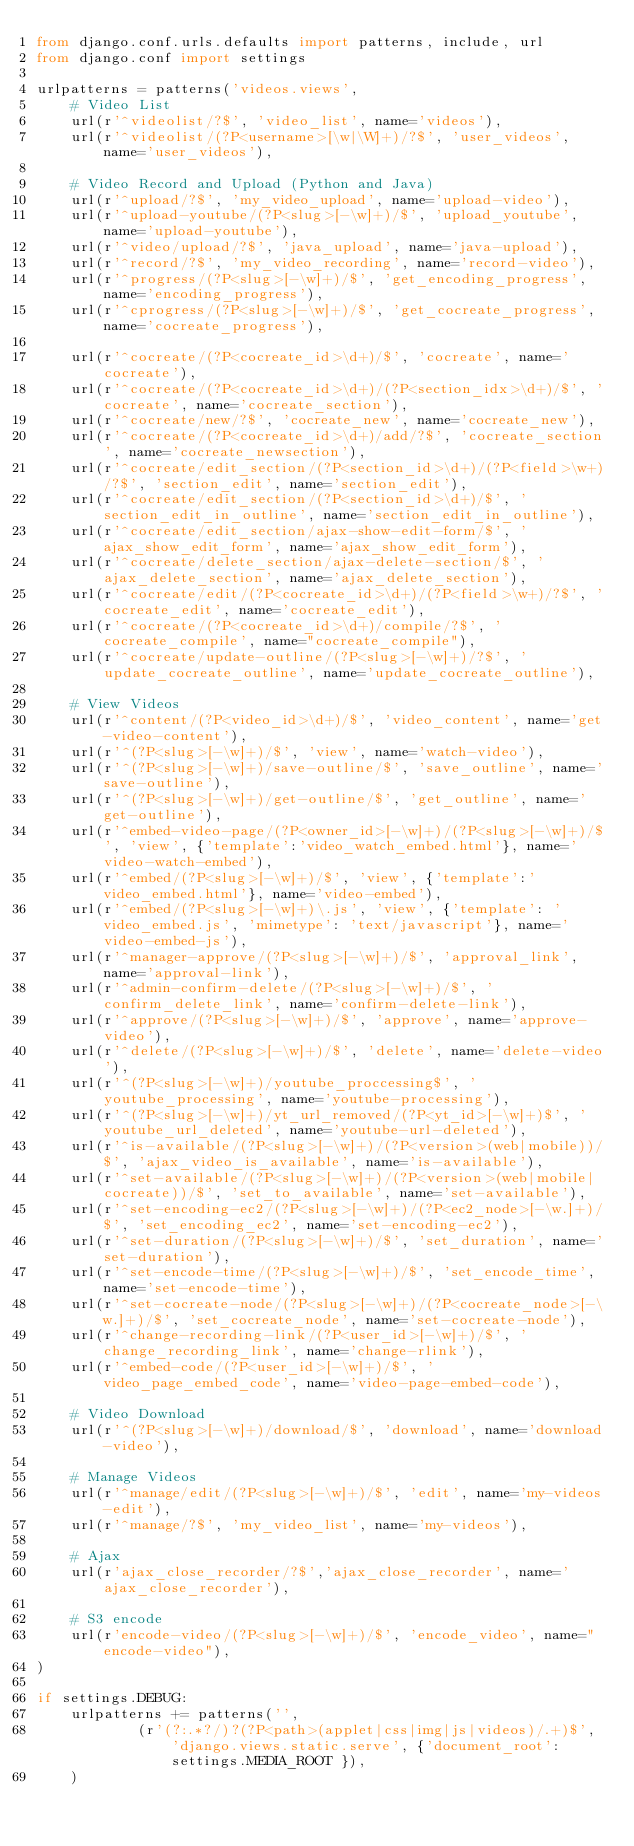<code> <loc_0><loc_0><loc_500><loc_500><_Python_>from django.conf.urls.defaults import patterns, include, url
from django.conf import settings

urlpatterns = patterns('videos.views',
    # Video List
    url(r'^videolist/?$', 'video_list', name='videos'),
    url(r'^videolist/(?P<username>[\w|\W]+)/?$', 'user_videos', name='user_videos'),

    # Video Record and Upload (Python and Java)
    url(r'^upload/?$', 'my_video_upload', name='upload-video'),
    url(r'^upload-youtube/(?P<slug>[-\w]+)/$', 'upload_youtube', name='upload-youtube'),
    url(r'^video/upload/?$', 'java_upload', name='java-upload'),
    url(r'^record/?$', 'my_video_recording', name='record-video'),
    url(r'^progress/(?P<slug>[-\w]+)/$', 'get_encoding_progress', name='encoding_progress'),
    url(r'^cprogress/(?P<slug>[-\w]+)/$', 'get_cocreate_progress', name='cocreate_progress'),

    url(r'^cocreate/(?P<cocreate_id>\d+)/$', 'cocreate', name='cocreate'),
    url(r'^cocreate/(?P<cocreate_id>\d+)/(?P<section_idx>\d+)/$', 'cocreate', name='cocreate_section'),
    url(r'^cocreate/new/?$', 'cocreate_new', name='cocreate_new'),
    url(r'^cocreate/(?P<cocreate_id>\d+)/add/?$', 'cocreate_section', name='cocreate_newsection'),
    url(r'^cocreate/edit_section/(?P<section_id>\d+)/(?P<field>\w+)/?$', 'section_edit', name='section_edit'),
    url(r'^cocreate/edit_section/(?P<section_id>\d+)/$', 'section_edit_in_outline', name='section_edit_in_outline'),
    url(r'^cocreate/edit_section/ajax-show-edit-form/$', 'ajax_show_edit_form', name='ajax_show_edit_form'),
    url(r'^cocreate/delete_section/ajax-delete-section/$', 'ajax_delete_section', name='ajax_delete_section'),
    url(r'^cocreate/edit/(?P<cocreate_id>\d+)/(?P<field>\w+)/?$', 'cocreate_edit', name='cocreate_edit'),
    url(r'^cocreate/(?P<cocreate_id>\d+)/compile/?$', 'cocreate_compile', name="cocreate_compile"),
    url(r'^cocreate/update-outline/(?P<slug>[-\w]+)/?$', 'update_cocreate_outline', name='update_cocreate_outline'),

    # View Videos
    url(r'^content/(?P<video_id>\d+)/$', 'video_content', name='get-video-content'),
    url(r'^(?P<slug>[-\w]+)/$', 'view', name='watch-video'),
    url(r'^(?P<slug>[-\w]+)/save-outline/$', 'save_outline', name='save-outline'),
    url(r'^(?P<slug>[-\w]+)/get-outline/$', 'get_outline', name='get-outline'),
    url(r'^embed-video-page/(?P<owner_id>[-\w]+)/(?P<slug>[-\w]+)/$', 'view', {'template':'video_watch_embed.html'}, name='video-watch-embed'),
    url(r'^embed/(?P<slug>[-\w]+)/$', 'view', {'template':'video_embed.html'}, name='video-embed'),
    url(r'^embed/(?P<slug>[-\w]+)\.js', 'view', {'template': 'video_embed.js', 'mimetype': 'text/javascript'}, name='video-embed-js'),
    url(r'^manager-approve/(?P<slug>[-\w]+)/$', 'approval_link', name='approval-link'),
    url(r'^admin-confirm-delete/(?P<slug>[-\w]+)/$', 'confirm_delete_link', name='confirm-delete-link'),
    url(r'^approve/(?P<slug>[-\w]+)/$', 'approve', name='approve-video'),
    url(r'^delete/(?P<slug>[-\w]+)/$', 'delete', name='delete-video'),
    url(r'^(?P<slug>[-\w]+)/youtube_proccessing$', 'youtube_processing', name='youtube-processing'),
    url(r'^(?P<slug>[-\w]+)/yt_url_removed/(?P<yt_id>[-\w]+)$', 'youtube_url_deleted', name='youtube-url-deleted'),
    url(r'^is-available/(?P<slug>[-\w]+)/(?P<version>(web|mobile))/$', 'ajax_video_is_available', name='is-available'),
    url(r'^set-available/(?P<slug>[-\w]+)/(?P<version>(web|mobile|cocreate))/$', 'set_to_available', name='set-available'),
    url(r'^set-encoding-ec2/(?P<slug>[-\w]+)/(?P<ec2_node>[-\w.]+)/$', 'set_encoding_ec2', name='set-encoding-ec2'),
    url(r'^set-duration/(?P<slug>[-\w]+)/$', 'set_duration', name='set-duration'),
    url(r'^set-encode-time/(?P<slug>[-\w]+)/$', 'set_encode_time', name='set-encode-time'),
    url(r'^set-cocreate-node/(?P<slug>[-\w]+)/(?P<cocreate_node>[-\w.]+)/$', 'set_cocreate_node', name='set-cocreate-node'),
    url(r'^change-recording-link/(?P<user_id>[-\w]+)/$', 'change_recording_link', name='change-rlink'),
    url(r'^embed-code/(?P<user_id>[-\w]+)/$', 'video_page_embed_code', name='video-page-embed-code'),

    # Video Download
    url(r'^(?P<slug>[-\w]+)/download/$', 'download', name='download-video'),

    # Manage Videos
    url(r'^manage/edit/(?P<slug>[-\w]+)/$', 'edit', name='my-videos-edit'),
    url(r'^manage/?$', 'my_video_list', name='my-videos'),

    # Ajax
    url(r'ajax_close_recorder/?$','ajax_close_recorder', name='ajax_close_recorder'),

    # S3 encode
    url(r'encode-video/(?P<slug>[-\w]+)/$', 'encode_video', name="encode-video"),
)

if settings.DEBUG:
    urlpatterns += patterns('',
            (r'(?:.*?/)?(?P<path>(applet|css|img|js|videos)/.+)$', 'django.views.static.serve', {'document_root': settings.MEDIA_ROOT }),
    )
</code> 